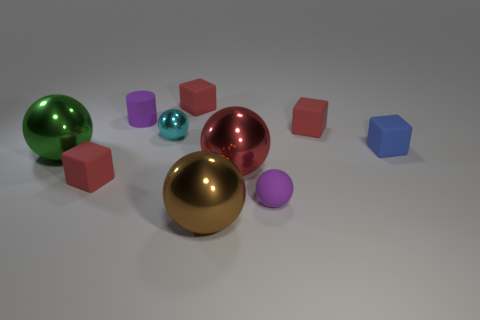Subtract all tiny purple balls. How many balls are left? 4 Subtract all blue cubes. How many cubes are left? 3 Subtract all yellow spheres. Subtract all blue cylinders. How many spheres are left? 5 Subtract all yellow cylinders. How many cyan balls are left? 1 Subtract all small green cylinders. Subtract all blocks. How many objects are left? 6 Add 3 cubes. How many cubes are left? 7 Add 3 brown metal objects. How many brown metal objects exist? 4 Subtract 0 gray cylinders. How many objects are left? 10 Subtract all blocks. How many objects are left? 6 Subtract 2 spheres. How many spheres are left? 3 